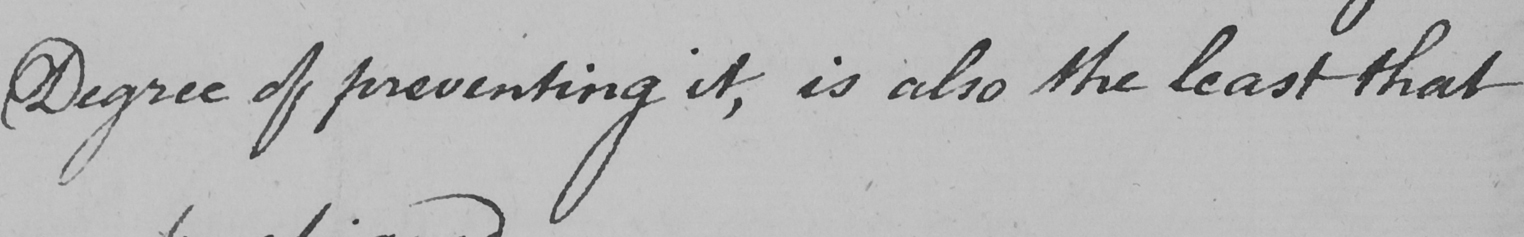What does this handwritten line say? Degree of preventing it , is also the least that 